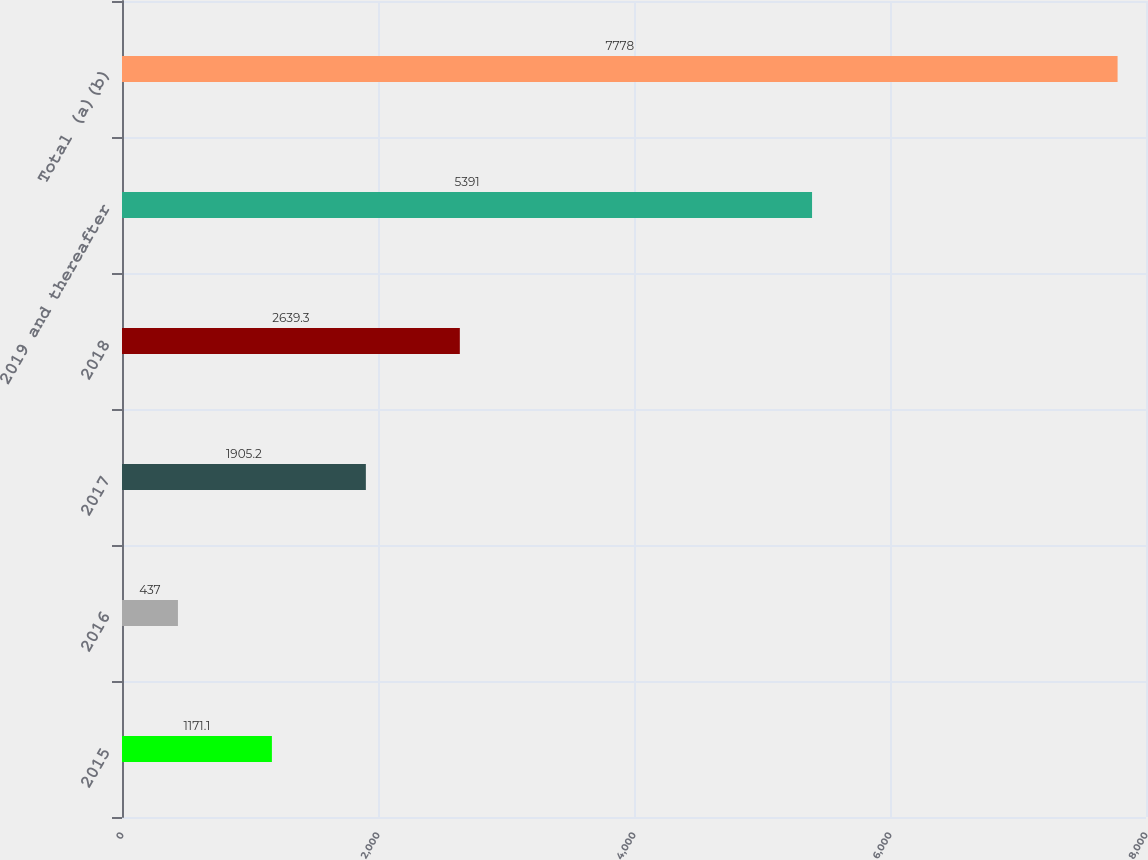Convert chart to OTSL. <chart><loc_0><loc_0><loc_500><loc_500><bar_chart><fcel>2015<fcel>2016<fcel>2017<fcel>2018<fcel>2019 and thereafter<fcel>Total (a)(b)<nl><fcel>1171.1<fcel>437<fcel>1905.2<fcel>2639.3<fcel>5391<fcel>7778<nl></chart> 